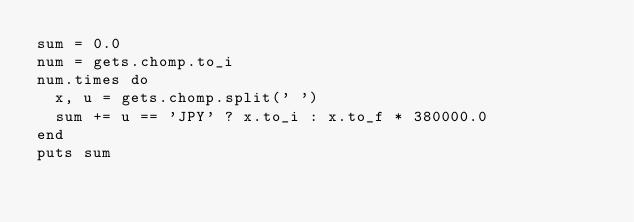<code> <loc_0><loc_0><loc_500><loc_500><_Ruby_>sum = 0.0
num = gets.chomp.to_i
num.times do
  x, u = gets.chomp.split(' ')
  sum += u == 'JPY' ? x.to_i : x.to_f * 380000.0
end
puts sum
</code> 